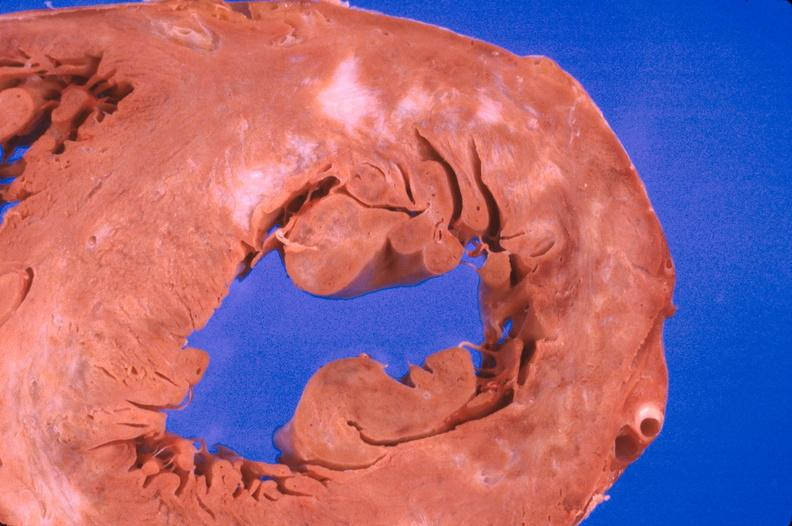does this image show heart, myocardial infarction free wall, 6 days old, in a patient with diabetes mellitus and hypertension?
Answer the question using a single word or phrase. Yes 